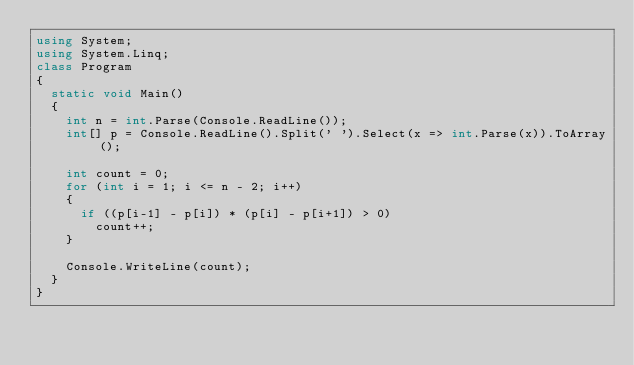Convert code to text. <code><loc_0><loc_0><loc_500><loc_500><_C#_>using System;
using System.Linq;
class Program
{
  static void Main()
  {
    int n = int.Parse(Console.ReadLine());
    int[] p = Console.ReadLine().Split(' ').Select(x => int.Parse(x)).ToArray();
    
    int count = 0;
    for (int i = 1; i <= n - 2; i++)
    {
      if ((p[i-1] - p[i]) * (p[i] - p[i+1]) > 0)
        count++;
    }
    
    Console.WriteLine(count);
  }
}</code> 